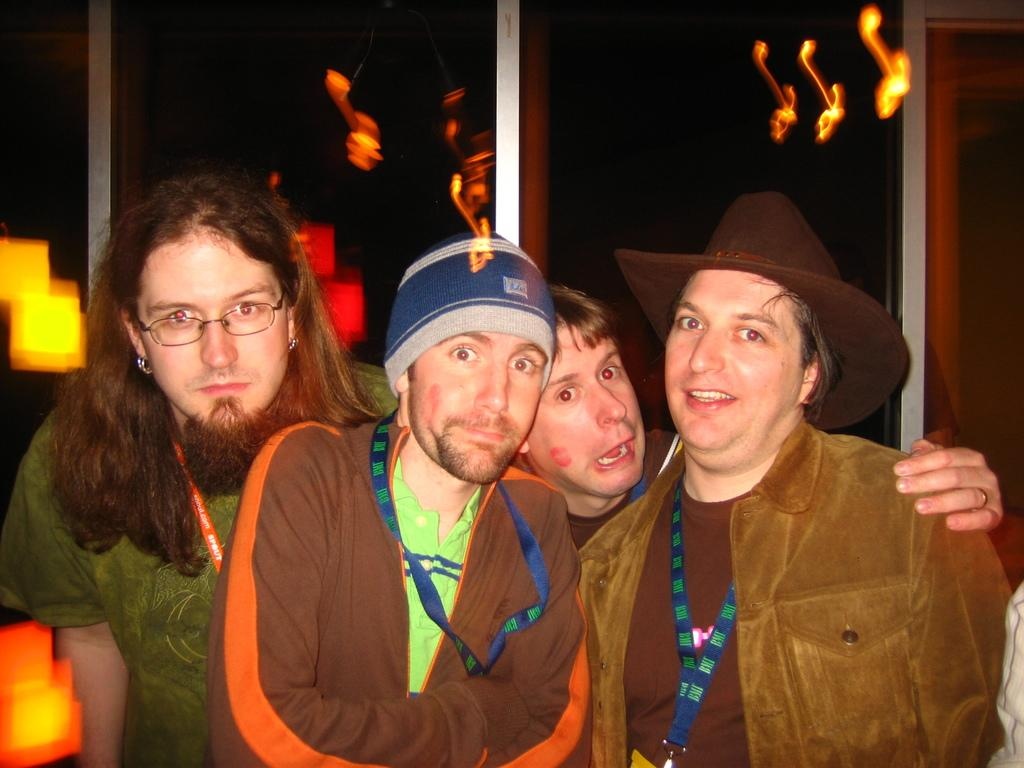How many people are present in the image? There are four people standing in the image. Can you describe any specific clothing or accessories worn by the people? One person is wearing a cap on the right side of the image. What type of plantation can be seen in the background of the image? There is no plantation visible in the image; it only shows four people standing. 